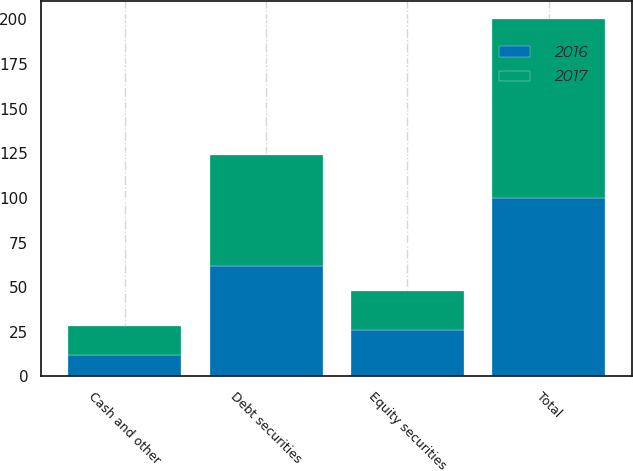Convert chart. <chart><loc_0><loc_0><loc_500><loc_500><stacked_bar_chart><ecel><fcel>Equity securities<fcel>Debt securities<fcel>Cash and other<fcel>Total<nl><fcel>2017<fcel>22<fcel>62<fcel>16<fcel>100<nl><fcel>2016<fcel>26<fcel>62<fcel>12<fcel>100<nl></chart> 